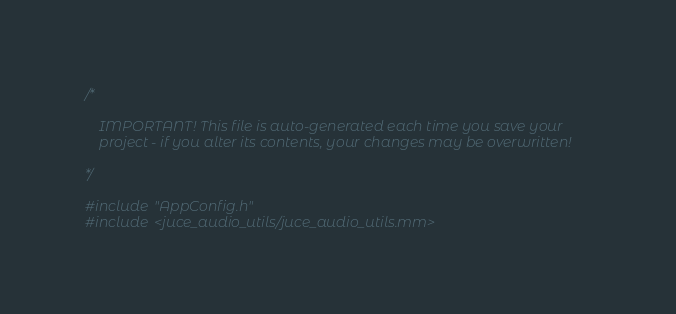Convert code to text. <code><loc_0><loc_0><loc_500><loc_500><_ObjectiveC_>/*

    IMPORTANT! This file is auto-generated each time you save your
    project - if you alter its contents, your changes may be overwritten!

*/

#include "AppConfig.h"
#include <juce_audio_utils/juce_audio_utils.mm>
</code> 